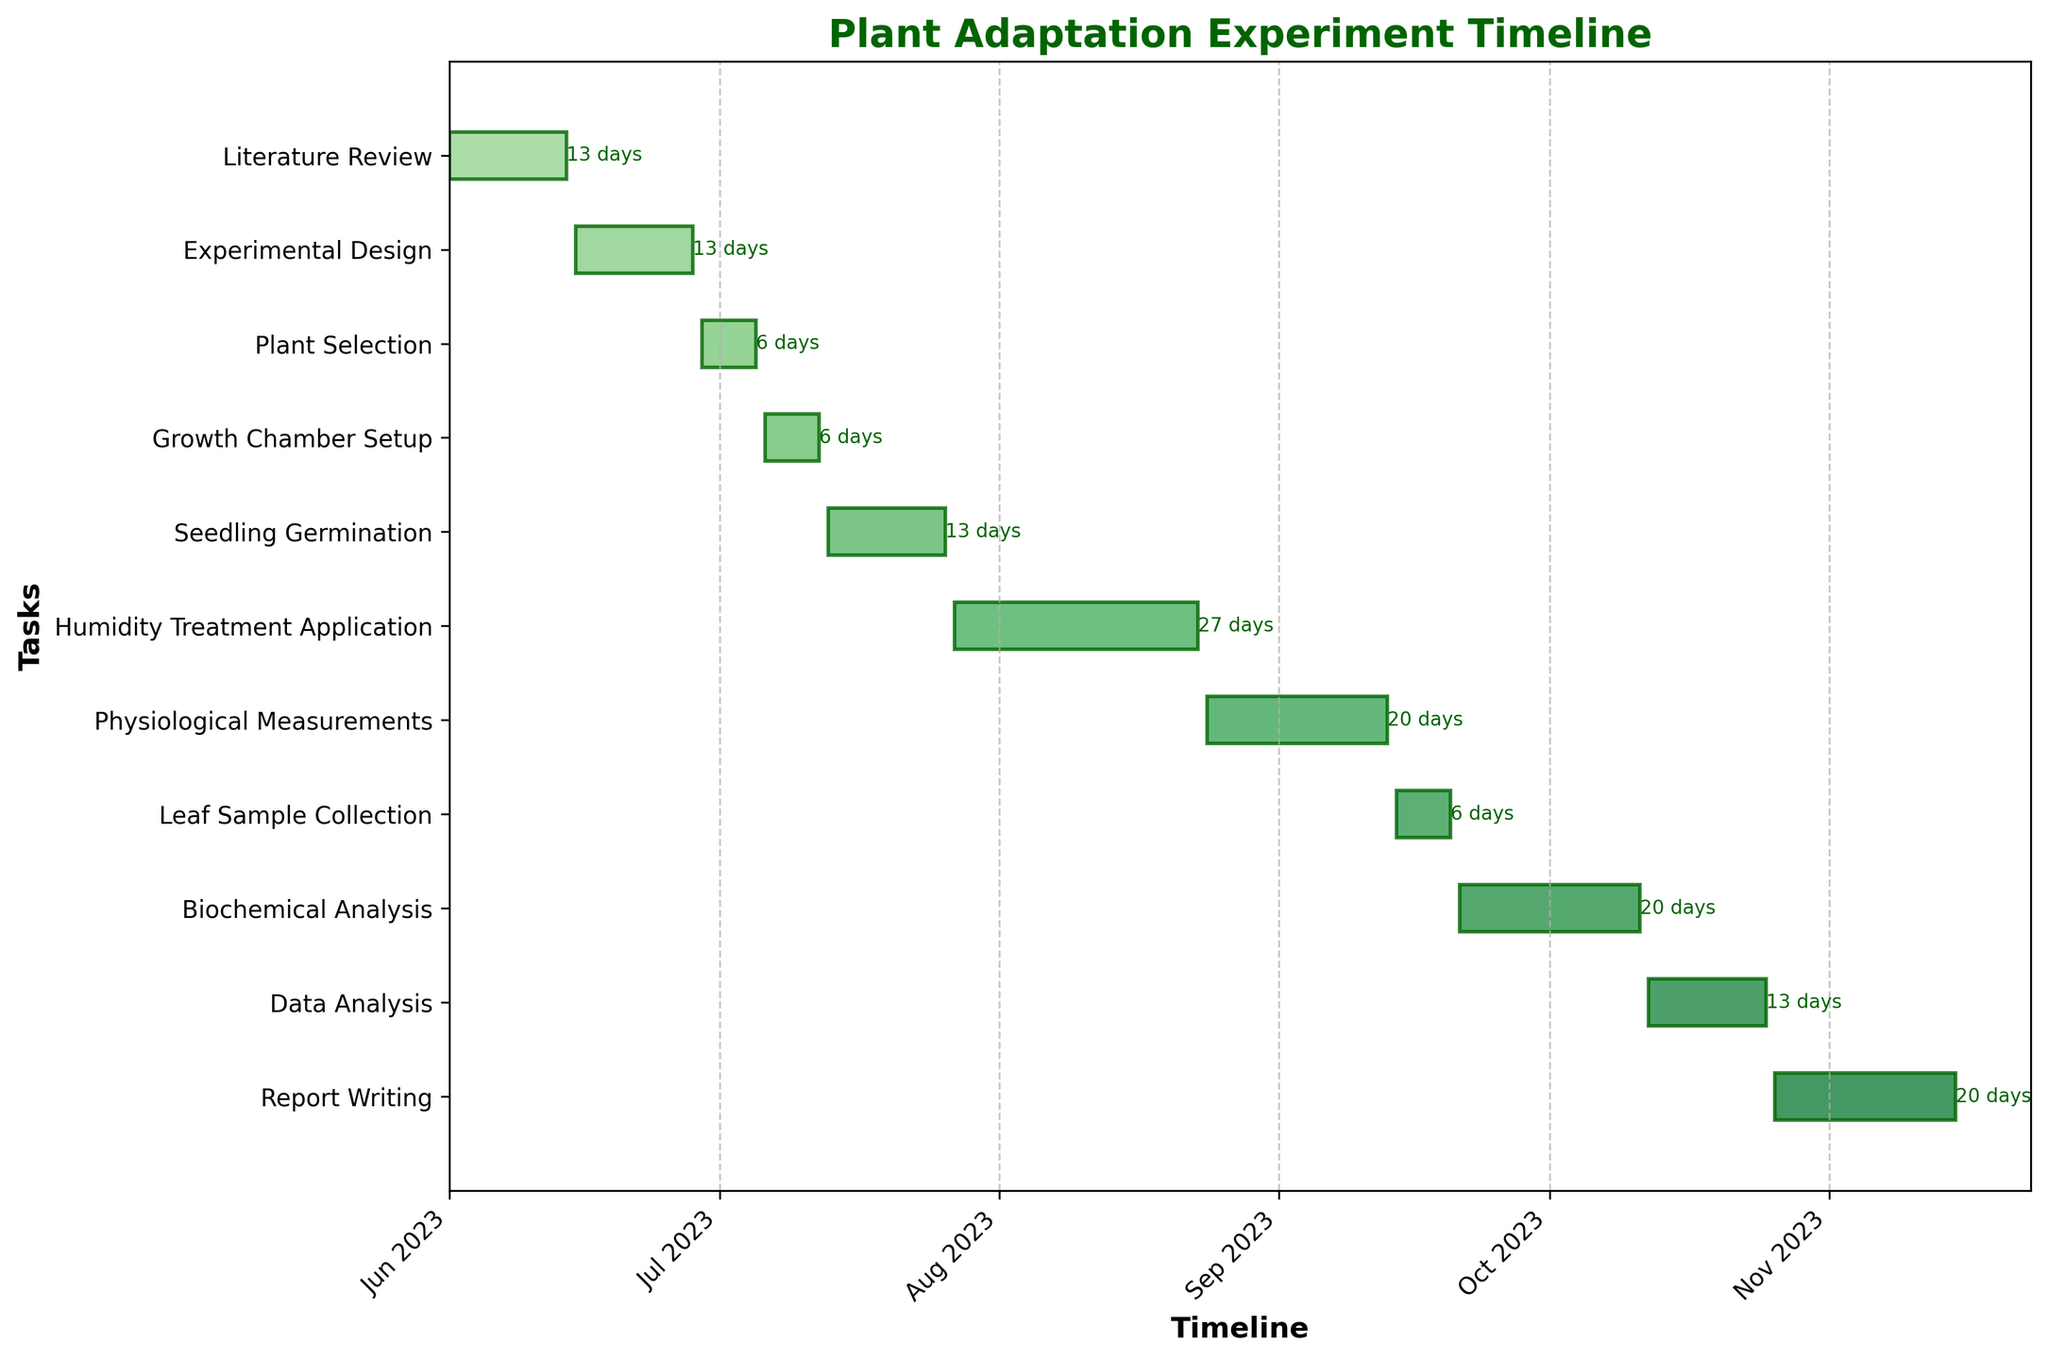Which task has the longest duration? To find the task with the longest duration, visually scan the Gantt chart for the bar that spans the most time horizontally. The task "Humidity Treatment Application" has the longest bar.
Answer: Humidity Treatment Application What is the title of the Gantt chart? The title is usually displayed at the top of the chart and reads "Plant Adaptation Experiment Timeline" in bold, dark green text.
Answer: Plant Adaptation Experiment Timeline How many days are allocated for Seedling Germination? Look at the "Seedling Germination" task and the text right next to the corresponding bar on the chart. The label shows 14 days.
Answer: 14 days Which tasks are scheduled before July 2023? Tasks scheduled before July 2023 are those whose end date is before July 1, 2023. In this case, "Literature Review," "Experimental Design," and "Plant Selection" are the tasks ending before July.
Answer: Literature Review, Experimental Design, Plant Selection Which two tasks overlap in their durations in mid-September? Find the tasks that are scheduled around mid-September. Both "Physiological Measurements" and "Leaf Sample Collection" span through mid-September as indicated by their bars on the Gantt chart.
Answer: Physiological Measurements, Leaf Sample Collection When does the "Growth Chamber Setup" task start and end? Locate the "Growth Chamber Setup" task on the Y-axis, then find the start and end dates as represented on the X-axis and the Gantt bar. It starts on July 6 and ends on July 12.
Answer: July 6 - July 12 Which task ends immediately before "Humidity Treatment Application"? Identify the task that ends on July 26, just before "Humidity Treatment Application" starts. "Seedling Germination" is the task that ends right before.
Answer: Seedling Germination How many tasks are scheduled to end in the month of October? Identify and count bars that end in October by their position along the X-axis. The tasks are "Biochemical Analysis" and "Data Analysis", so there are 2 tasks.
Answer: 2 tasks What is the total duration in days for "Data Analysis" and "Report Writing"? Add the durations of the "Data Analysis" task (14 days) and the "Report Writing" task (21 days).
Answer: 35 days What is the average duration of all the tasks? Add up the durations of all tasks and divide by the number of tasks: (14 + 14 + 7 + 7 + 14 + 28 + 21 + 7 + 21 + 14 + 21) / 11. The sum is 189 days, hence the average is 189 / 11 = 17.18 days.
Answer: 17.18 days 